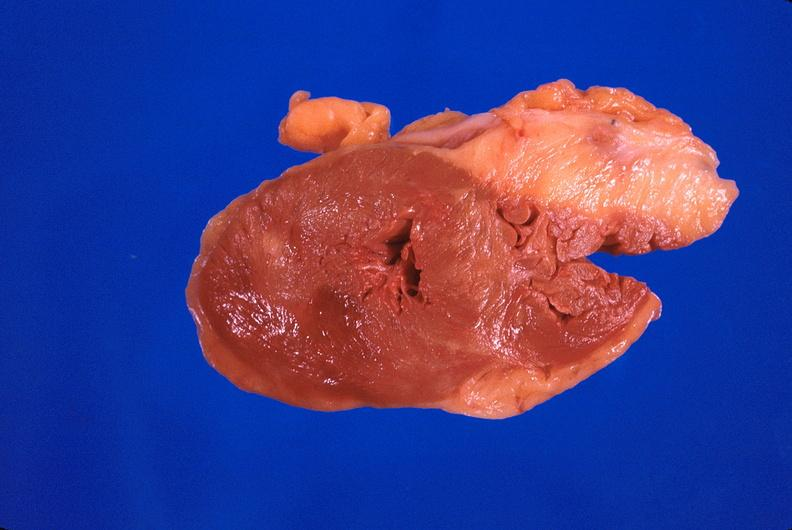what does this image show?
Answer the question using a single word or phrase. Heart 